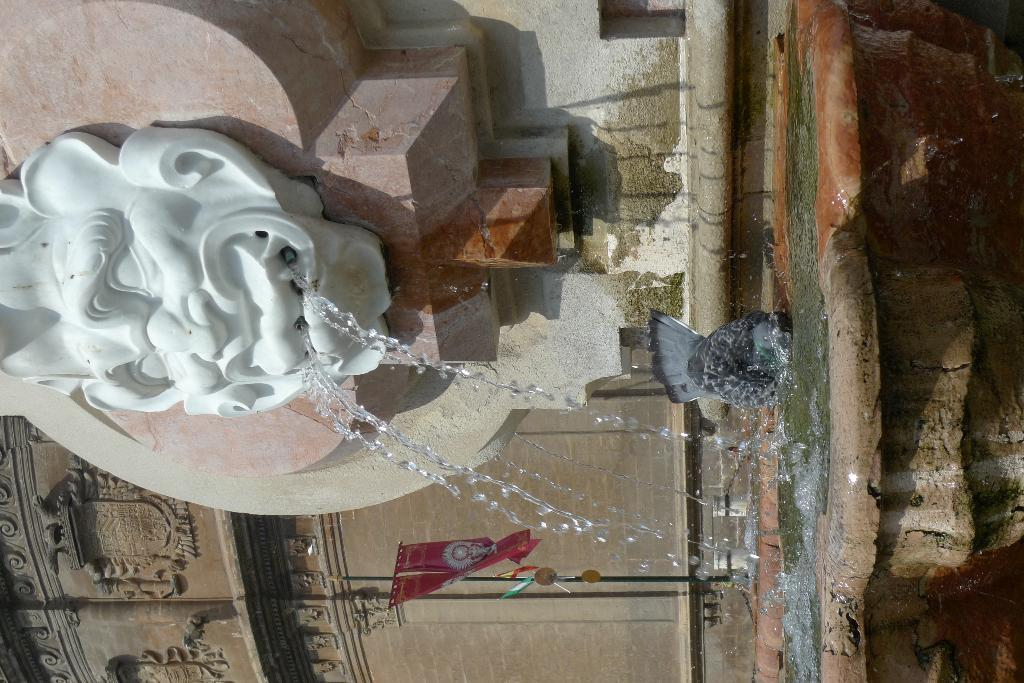What is the main feature in the image? There is a water fountain in the image. Can you describe anything else in the image besides the water fountain? Yes, there is art on the wall in the image. What type of science experiment is being conducted on the ship in the image? There is no ship or science experiment present in the image; it features a water fountain and art on the wall. What type of iron is used to create the art on the wall in the image? There is no information about the materials used to create the art on the wall in the image. 